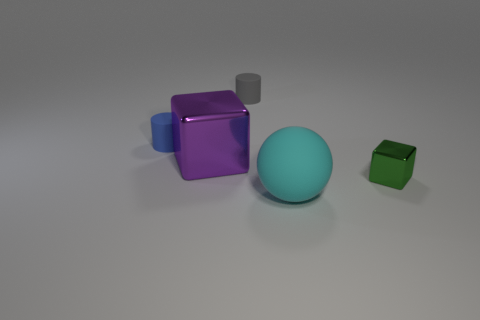Are there any other things of the same color as the large sphere?
Provide a short and direct response. No. Does the shiny object to the right of the large cube have the same shape as the shiny object behind the small metallic cube?
Ensure brevity in your answer.  Yes. There is another shiny thing that is the same size as the blue object; what is its shape?
Your answer should be very brief. Cube. What color is the big sphere that is made of the same material as the gray cylinder?
Your response must be concise. Cyan. Do the large matte thing and the small thing on the left side of the large metallic object have the same shape?
Your answer should be very brief. No. There is a purple thing that is the same size as the cyan rubber sphere; what material is it?
Your response must be concise. Metal. Is there a cylinder of the same color as the big cube?
Ensure brevity in your answer.  No. What is the shape of the thing that is behind the big cube and left of the gray matte cylinder?
Ensure brevity in your answer.  Cylinder. How many small gray cylinders have the same material as the large purple thing?
Offer a very short reply. 0. Are there fewer balls that are on the right side of the small block than green shiny things that are behind the purple block?
Offer a terse response. No. 